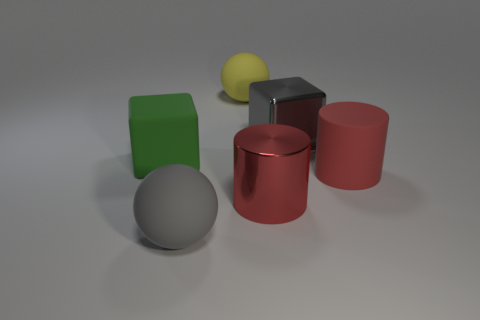Does the big shiny thing that is behind the red matte thing have the same shape as the large shiny object that is in front of the green rubber thing?
Your response must be concise. No. There is a block that is right of the large gray matte ball; what size is it?
Your answer should be compact. Large. There is a matte ball that is in front of the shiny object behind the large green object; how big is it?
Ensure brevity in your answer.  Large. Are there more large gray objects than big cyan matte cylinders?
Give a very brief answer. Yes. Are there more large spheres behind the big gray matte sphere than gray shiny cubes to the right of the big rubber cylinder?
Offer a terse response. Yes. There is a matte object that is both in front of the metallic block and to the right of the large gray rubber ball; what size is it?
Provide a succinct answer. Large. What number of other matte objects are the same size as the green rubber object?
Ensure brevity in your answer.  3. What material is the other cylinder that is the same color as the rubber cylinder?
Keep it short and to the point. Metal. Is the shape of the matte object on the left side of the large gray ball the same as  the gray metallic object?
Offer a very short reply. Yes. Is the number of matte blocks behind the yellow rubber ball less than the number of big red objects?
Ensure brevity in your answer.  Yes. 